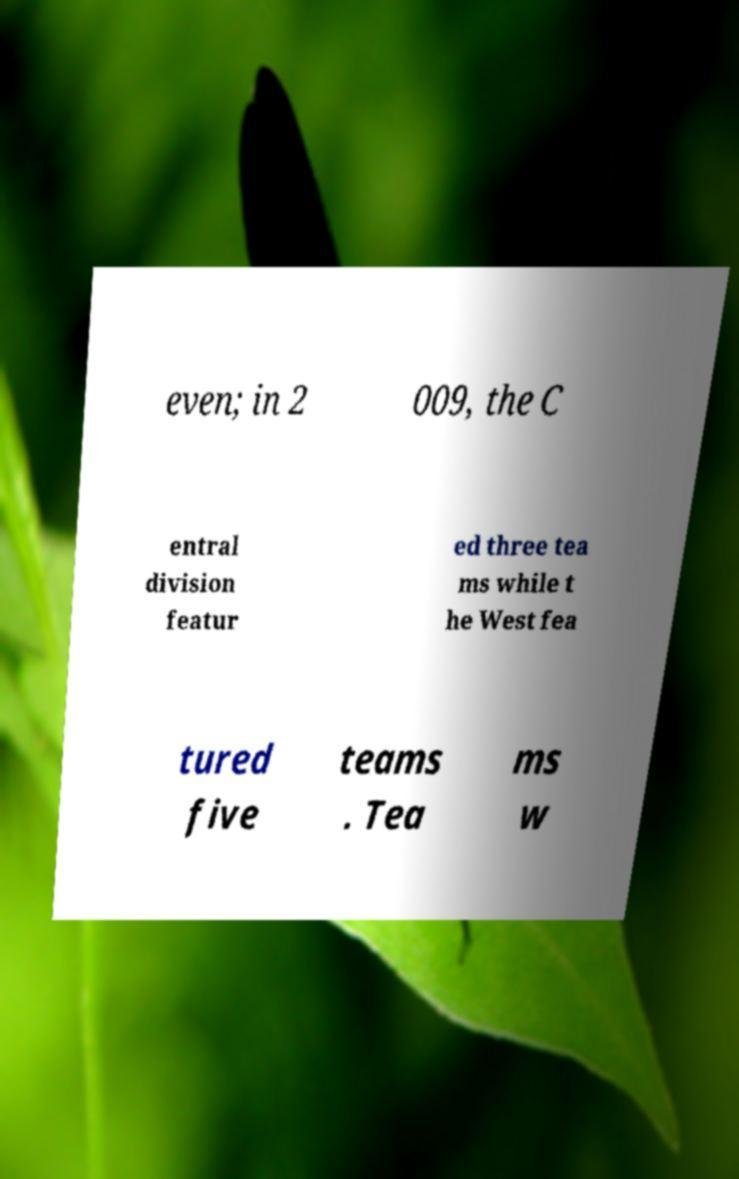Could you extract and type out the text from this image? even; in 2 009, the C entral division featur ed three tea ms while t he West fea tured five teams . Tea ms w 